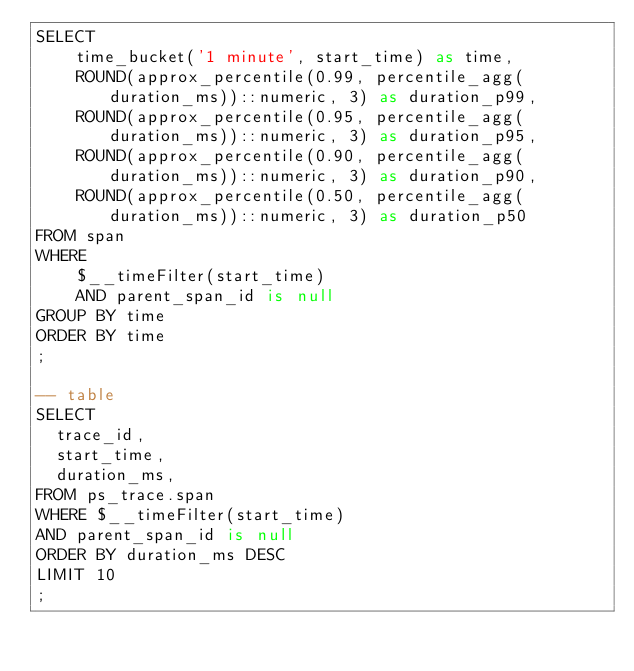<code> <loc_0><loc_0><loc_500><loc_500><_SQL_>SELECT
    time_bucket('1 minute', start_time) as time,
    ROUND(approx_percentile(0.99, percentile_agg(duration_ms))::numeric, 3) as duration_p99,
    ROUND(approx_percentile(0.95, percentile_agg(duration_ms))::numeric, 3) as duration_p95,
    ROUND(approx_percentile(0.90, percentile_agg(duration_ms))::numeric, 3) as duration_p90,
    ROUND(approx_percentile(0.50, percentile_agg(duration_ms))::numeric, 3) as duration_p50
FROM span
WHERE
    $__timeFilter(start_time)
    AND parent_span_id is null
GROUP BY time
ORDER BY time
;

-- table
SELECT
  trace_id,
  start_time,
  duration_ms,
FROM ps_trace.span
WHERE $__timeFilter(start_time)
AND parent_span_id is null
ORDER BY duration_ms DESC
LIMIT 10
;
</code> 